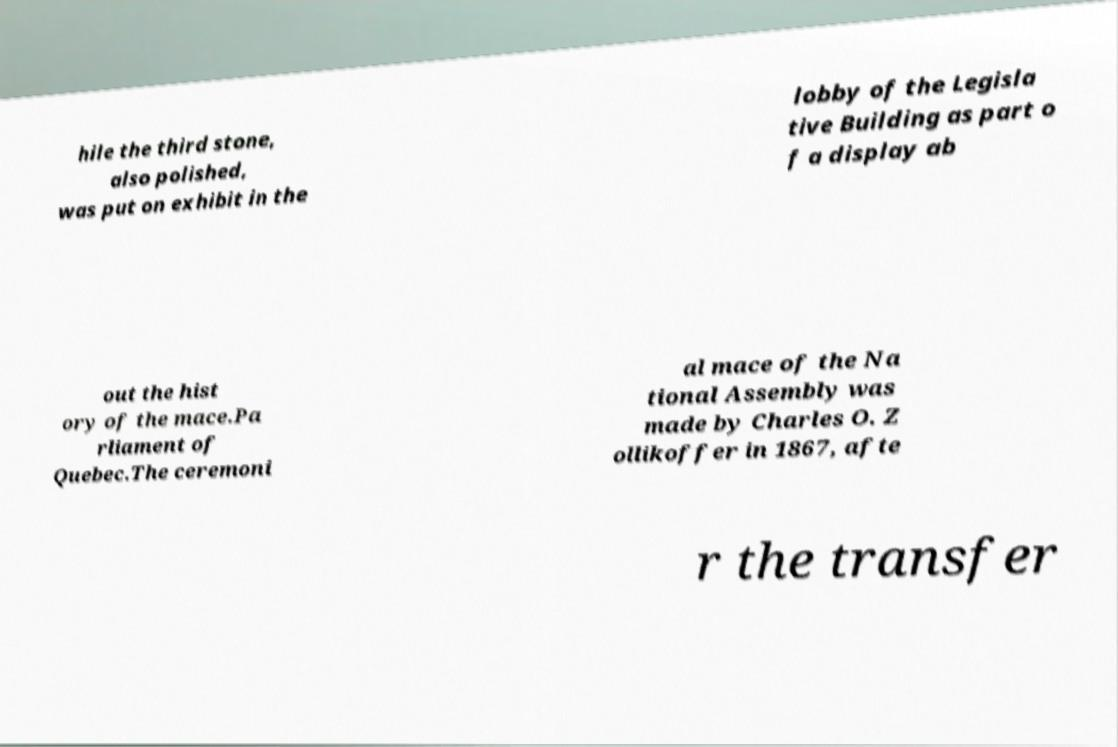Please read and relay the text visible in this image. What does it say? hile the third stone, also polished, was put on exhibit in the lobby of the Legisla tive Building as part o f a display ab out the hist ory of the mace.Pa rliament of Quebec.The ceremoni al mace of the Na tional Assembly was made by Charles O. Z ollikoffer in 1867, afte r the transfer 